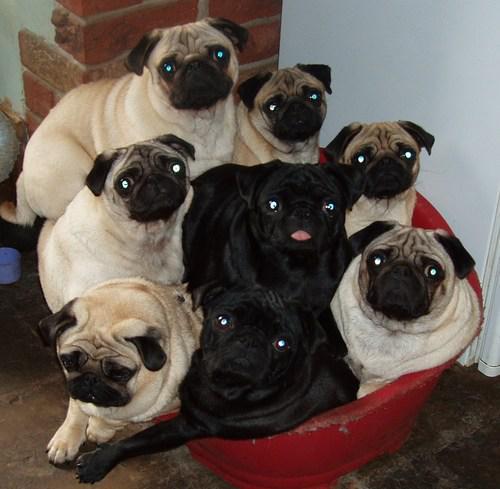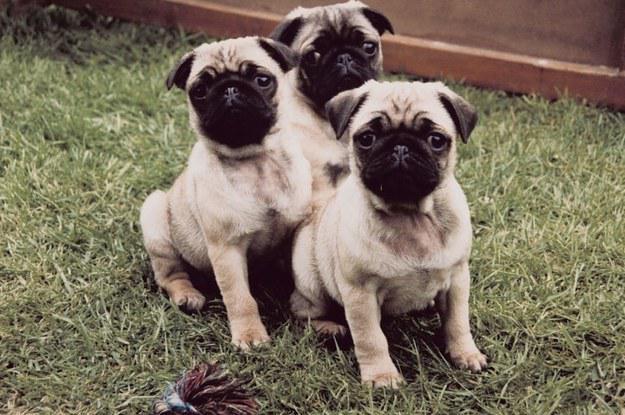The first image is the image on the left, the second image is the image on the right. Analyze the images presented: Is the assertion "There are exactly three dogs in the image on the right." valid? Answer yes or no. Yes. 